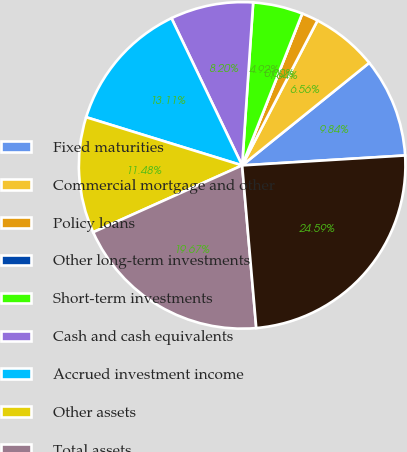Convert chart to OTSL. <chart><loc_0><loc_0><loc_500><loc_500><pie_chart><fcel>Fixed maturities<fcel>Commercial mortgage and other<fcel>Policy loans<fcel>Other long-term investments<fcel>Short-term investments<fcel>Cash and cash equivalents<fcel>Accrued investment income<fcel>Other assets<fcel>Total assets<fcel>Policyholders' account<nl><fcel>9.84%<fcel>6.56%<fcel>1.64%<fcel>0.0%<fcel>4.92%<fcel>8.2%<fcel>13.11%<fcel>11.48%<fcel>19.67%<fcel>24.59%<nl></chart> 